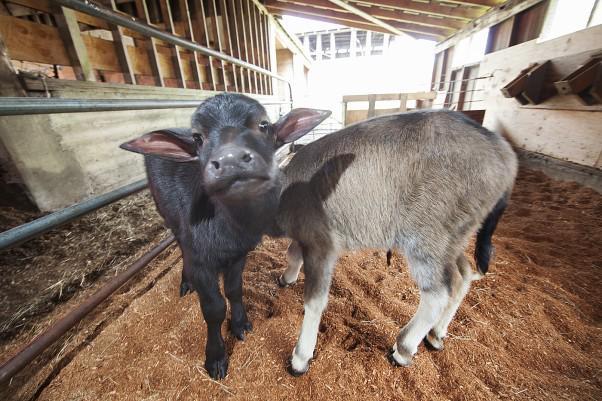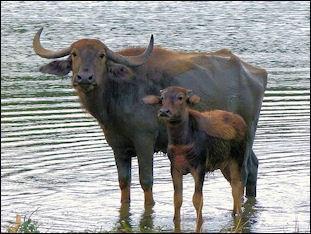The first image is the image on the left, the second image is the image on the right. Analyze the images presented: Is the assertion "A calf is being fed by it's mother" valid? Answer yes or no. No. 